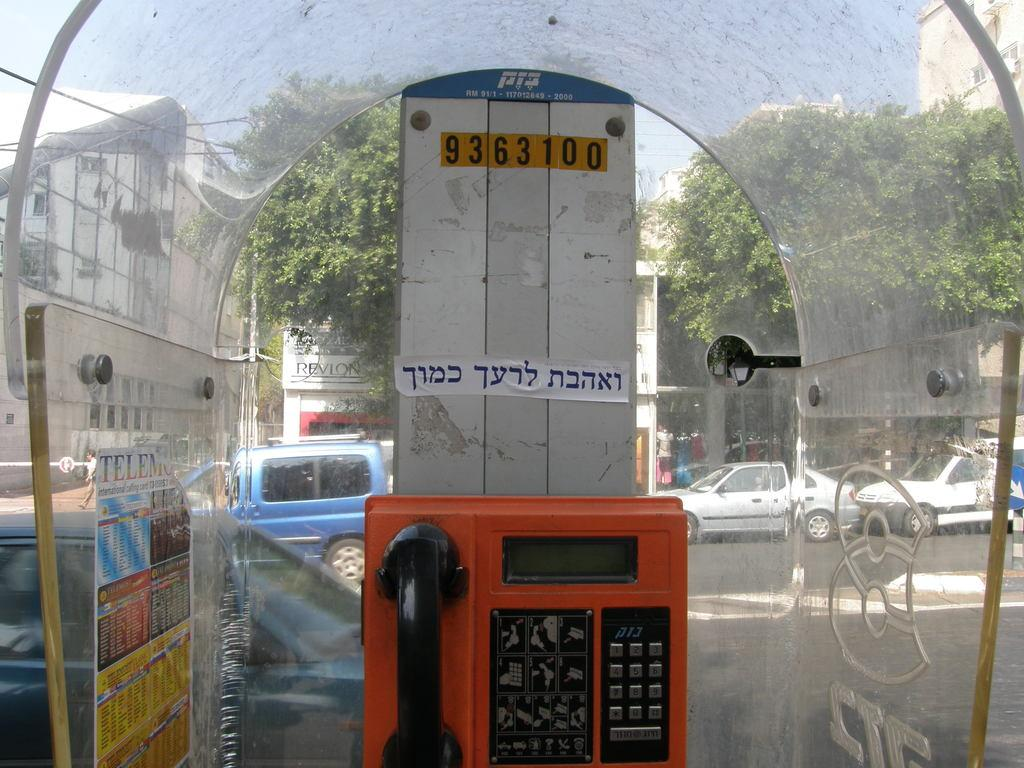What object can be seen in the image that is used for communication? There is a telephone in the image. What is on the glass surface in the image? There is a poster on a glass surface. What can be seen in the background of the image? The background of the image includes buildings, vehicles, and trees. Can you see any fish swimming in the lake in the image? There is no lake or fish present in the image. What type of sheet is covering the telephone in the image? There is no sheet covering the telephone in the image; it is not mentioned in the provided facts. 